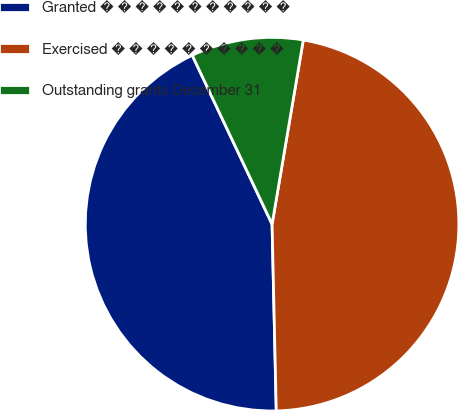Convert chart. <chart><loc_0><loc_0><loc_500><loc_500><pie_chart><fcel>Granted � � � � � � � � � � �<fcel>Exercised � � � � � � � � � �<fcel>Outstanding grants December 31<nl><fcel>43.33%<fcel>46.97%<fcel>9.7%<nl></chart> 